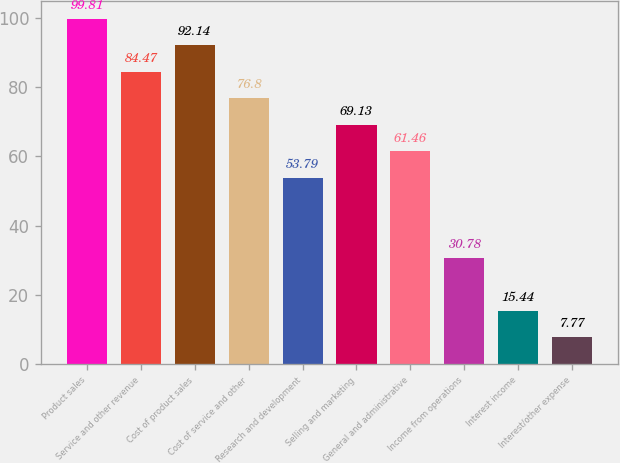<chart> <loc_0><loc_0><loc_500><loc_500><bar_chart><fcel>Product sales<fcel>Service and other revenue<fcel>Cost of product sales<fcel>Cost of service and other<fcel>Research and development<fcel>Selling and marketing<fcel>General and administrative<fcel>Income from operations<fcel>Interest income<fcel>Interest/other expense<nl><fcel>99.81<fcel>84.47<fcel>92.14<fcel>76.8<fcel>53.79<fcel>69.13<fcel>61.46<fcel>30.78<fcel>15.44<fcel>7.77<nl></chart> 